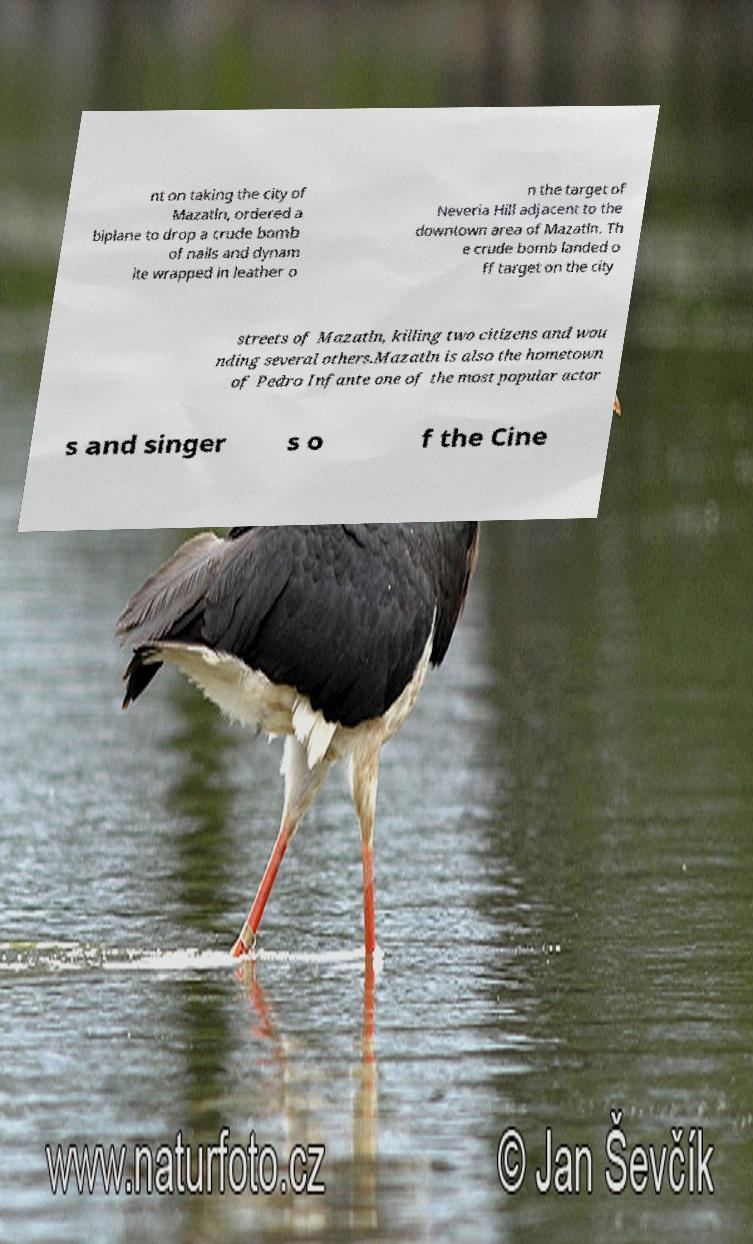Please identify and transcribe the text found in this image. nt on taking the city of Mazatln, ordered a biplane to drop a crude bomb of nails and dynam ite wrapped in leather o n the target of Neveria Hill adjacent to the downtown area of Mazatln. Th e crude bomb landed o ff target on the city streets of Mazatln, killing two citizens and wou nding several others.Mazatln is also the hometown of Pedro Infante one of the most popular actor s and singer s o f the Cine 